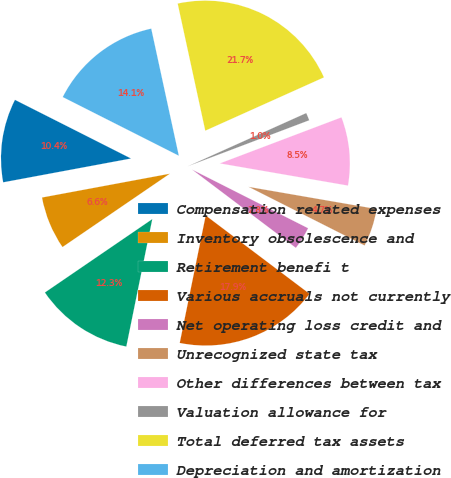Convert chart to OTSL. <chart><loc_0><loc_0><loc_500><loc_500><pie_chart><fcel>Compensation related expenses<fcel>Inventory obsolescence and<fcel>Retirement benefi t<fcel>Various accruals not currently<fcel>Net operating loss credit and<fcel>Unrecognized state tax<fcel>Other differences between tax<fcel>Valuation allowance for<fcel>Total deferred tax assets<fcel>Depreciation and amortization<nl><fcel>10.38%<fcel>6.61%<fcel>12.26%<fcel>17.91%<fcel>2.84%<fcel>4.72%<fcel>8.49%<fcel>0.96%<fcel>21.68%<fcel>14.15%<nl></chart> 